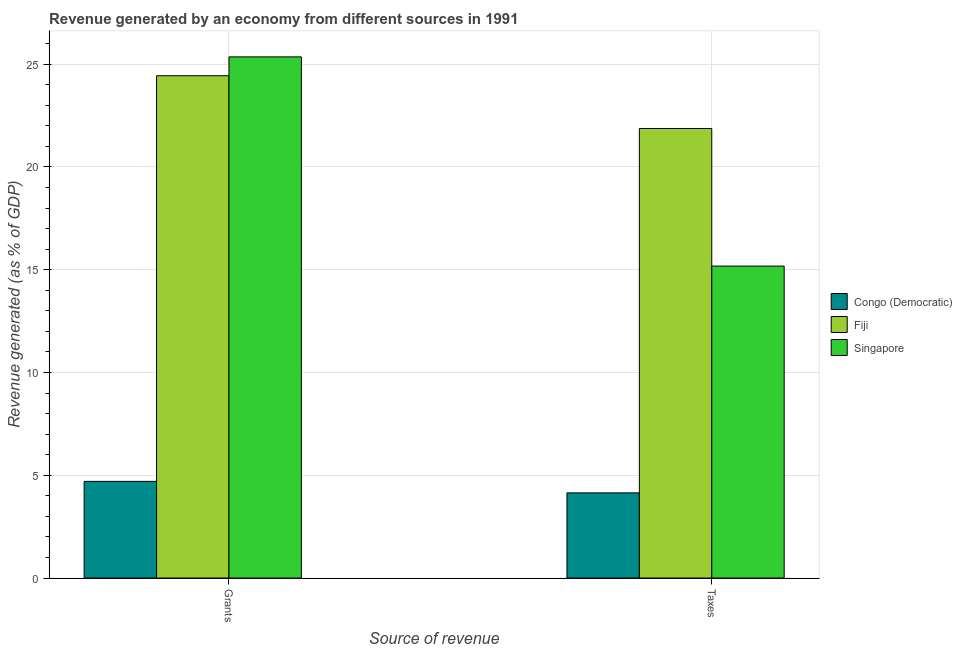How many different coloured bars are there?
Keep it short and to the point. 3. How many bars are there on the 1st tick from the left?
Offer a terse response. 3. What is the label of the 2nd group of bars from the left?
Your answer should be very brief. Taxes. What is the revenue generated by taxes in Singapore?
Your answer should be compact. 15.18. Across all countries, what is the maximum revenue generated by taxes?
Keep it short and to the point. 21.87. Across all countries, what is the minimum revenue generated by grants?
Provide a short and direct response. 4.7. In which country was the revenue generated by grants maximum?
Your answer should be compact. Singapore. In which country was the revenue generated by taxes minimum?
Keep it short and to the point. Congo (Democratic). What is the total revenue generated by taxes in the graph?
Your answer should be compact. 41.19. What is the difference between the revenue generated by taxes in Singapore and that in Fiji?
Your response must be concise. -6.69. What is the difference between the revenue generated by grants in Singapore and the revenue generated by taxes in Fiji?
Your answer should be compact. 3.48. What is the average revenue generated by grants per country?
Ensure brevity in your answer.  18.17. What is the difference between the revenue generated by taxes and revenue generated by grants in Congo (Democratic)?
Ensure brevity in your answer.  -0.56. In how many countries, is the revenue generated by taxes greater than 5 %?
Keep it short and to the point. 2. What is the ratio of the revenue generated by taxes in Congo (Democratic) to that in Fiji?
Your response must be concise. 0.19. What does the 1st bar from the left in Grants represents?
Your response must be concise. Congo (Democratic). What does the 1st bar from the right in Grants represents?
Make the answer very short. Singapore. What is the difference between two consecutive major ticks on the Y-axis?
Give a very brief answer. 5. Where does the legend appear in the graph?
Provide a short and direct response. Center right. How many legend labels are there?
Your answer should be very brief. 3. What is the title of the graph?
Offer a terse response. Revenue generated by an economy from different sources in 1991. What is the label or title of the X-axis?
Provide a succinct answer. Source of revenue. What is the label or title of the Y-axis?
Offer a terse response. Revenue generated (as % of GDP). What is the Revenue generated (as % of GDP) in Congo (Democratic) in Grants?
Provide a succinct answer. 4.7. What is the Revenue generated (as % of GDP) of Fiji in Grants?
Offer a terse response. 24.44. What is the Revenue generated (as % of GDP) of Singapore in Grants?
Your answer should be compact. 25.36. What is the Revenue generated (as % of GDP) of Congo (Democratic) in Taxes?
Keep it short and to the point. 4.14. What is the Revenue generated (as % of GDP) in Fiji in Taxes?
Provide a short and direct response. 21.87. What is the Revenue generated (as % of GDP) in Singapore in Taxes?
Your response must be concise. 15.18. Across all Source of revenue, what is the maximum Revenue generated (as % of GDP) in Congo (Democratic)?
Give a very brief answer. 4.7. Across all Source of revenue, what is the maximum Revenue generated (as % of GDP) of Fiji?
Offer a terse response. 24.44. Across all Source of revenue, what is the maximum Revenue generated (as % of GDP) in Singapore?
Keep it short and to the point. 25.36. Across all Source of revenue, what is the minimum Revenue generated (as % of GDP) in Congo (Democratic)?
Offer a terse response. 4.14. Across all Source of revenue, what is the minimum Revenue generated (as % of GDP) of Fiji?
Ensure brevity in your answer.  21.87. Across all Source of revenue, what is the minimum Revenue generated (as % of GDP) in Singapore?
Provide a short and direct response. 15.18. What is the total Revenue generated (as % of GDP) of Congo (Democratic) in the graph?
Your response must be concise. 8.85. What is the total Revenue generated (as % of GDP) of Fiji in the graph?
Ensure brevity in your answer.  46.31. What is the total Revenue generated (as % of GDP) in Singapore in the graph?
Keep it short and to the point. 40.53. What is the difference between the Revenue generated (as % of GDP) in Congo (Democratic) in Grants and that in Taxes?
Ensure brevity in your answer.  0.56. What is the difference between the Revenue generated (as % of GDP) of Fiji in Grants and that in Taxes?
Give a very brief answer. 2.57. What is the difference between the Revenue generated (as % of GDP) in Singapore in Grants and that in Taxes?
Give a very brief answer. 10.18. What is the difference between the Revenue generated (as % of GDP) of Congo (Democratic) in Grants and the Revenue generated (as % of GDP) of Fiji in Taxes?
Provide a succinct answer. -17.17. What is the difference between the Revenue generated (as % of GDP) of Congo (Democratic) in Grants and the Revenue generated (as % of GDP) of Singapore in Taxes?
Keep it short and to the point. -10.48. What is the difference between the Revenue generated (as % of GDP) in Fiji in Grants and the Revenue generated (as % of GDP) in Singapore in Taxes?
Provide a short and direct response. 9.26. What is the average Revenue generated (as % of GDP) of Congo (Democratic) per Source of revenue?
Make the answer very short. 4.42. What is the average Revenue generated (as % of GDP) in Fiji per Source of revenue?
Offer a terse response. 23.16. What is the average Revenue generated (as % of GDP) of Singapore per Source of revenue?
Provide a succinct answer. 20.27. What is the difference between the Revenue generated (as % of GDP) of Congo (Democratic) and Revenue generated (as % of GDP) of Fiji in Grants?
Your response must be concise. -19.74. What is the difference between the Revenue generated (as % of GDP) of Congo (Democratic) and Revenue generated (as % of GDP) of Singapore in Grants?
Offer a terse response. -20.65. What is the difference between the Revenue generated (as % of GDP) of Fiji and Revenue generated (as % of GDP) of Singapore in Grants?
Make the answer very short. -0.92. What is the difference between the Revenue generated (as % of GDP) in Congo (Democratic) and Revenue generated (as % of GDP) in Fiji in Taxes?
Offer a terse response. -17.73. What is the difference between the Revenue generated (as % of GDP) of Congo (Democratic) and Revenue generated (as % of GDP) of Singapore in Taxes?
Offer a very short reply. -11.03. What is the difference between the Revenue generated (as % of GDP) of Fiji and Revenue generated (as % of GDP) of Singapore in Taxes?
Provide a succinct answer. 6.69. What is the ratio of the Revenue generated (as % of GDP) of Congo (Democratic) in Grants to that in Taxes?
Give a very brief answer. 1.13. What is the ratio of the Revenue generated (as % of GDP) of Fiji in Grants to that in Taxes?
Make the answer very short. 1.12. What is the ratio of the Revenue generated (as % of GDP) of Singapore in Grants to that in Taxes?
Offer a terse response. 1.67. What is the difference between the highest and the second highest Revenue generated (as % of GDP) of Congo (Democratic)?
Provide a short and direct response. 0.56. What is the difference between the highest and the second highest Revenue generated (as % of GDP) in Fiji?
Your answer should be very brief. 2.57. What is the difference between the highest and the second highest Revenue generated (as % of GDP) of Singapore?
Offer a terse response. 10.18. What is the difference between the highest and the lowest Revenue generated (as % of GDP) of Congo (Democratic)?
Your answer should be compact. 0.56. What is the difference between the highest and the lowest Revenue generated (as % of GDP) in Fiji?
Offer a very short reply. 2.57. What is the difference between the highest and the lowest Revenue generated (as % of GDP) of Singapore?
Keep it short and to the point. 10.18. 